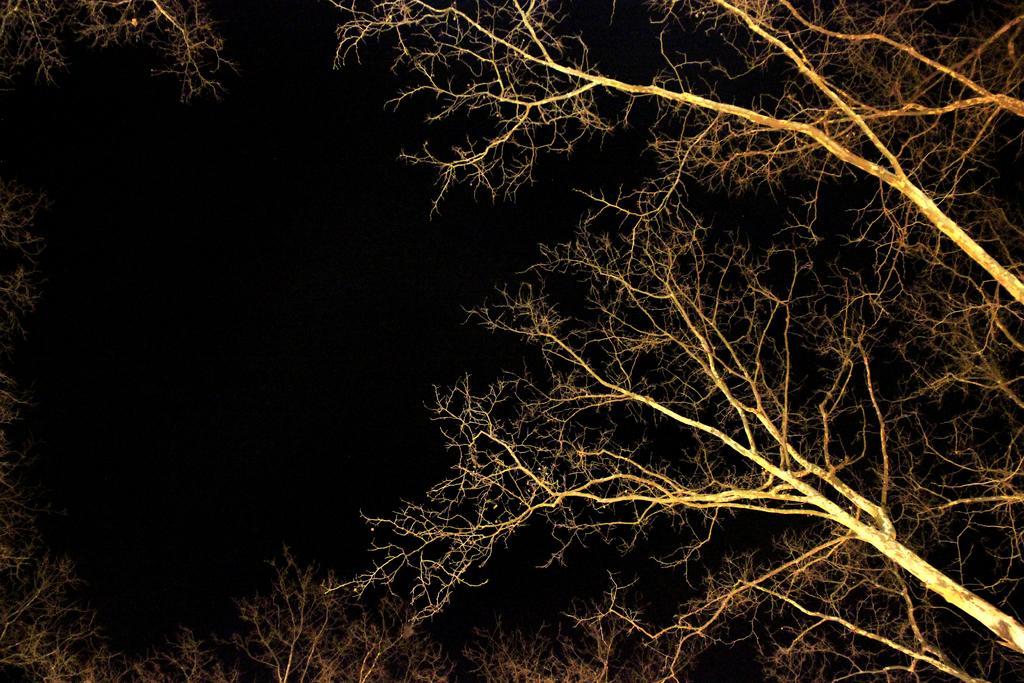Describe this image in one or two sentences. This picture contains many trees. On the left corner of the picture, it is black in color and this picture is clicked in the dark. 